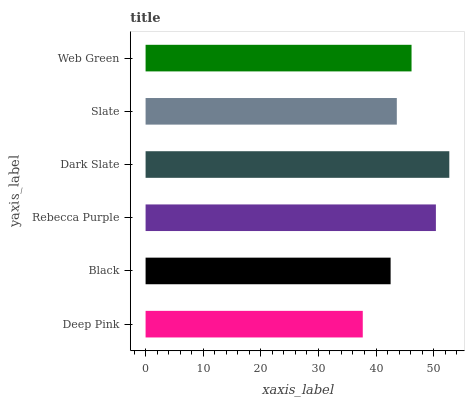Is Deep Pink the minimum?
Answer yes or no. Yes. Is Dark Slate the maximum?
Answer yes or no. Yes. Is Black the minimum?
Answer yes or no. No. Is Black the maximum?
Answer yes or no. No. Is Black greater than Deep Pink?
Answer yes or no. Yes. Is Deep Pink less than Black?
Answer yes or no. Yes. Is Deep Pink greater than Black?
Answer yes or no. No. Is Black less than Deep Pink?
Answer yes or no. No. Is Web Green the high median?
Answer yes or no. Yes. Is Slate the low median?
Answer yes or no. Yes. Is Rebecca Purple the high median?
Answer yes or no. No. Is Deep Pink the low median?
Answer yes or no. No. 